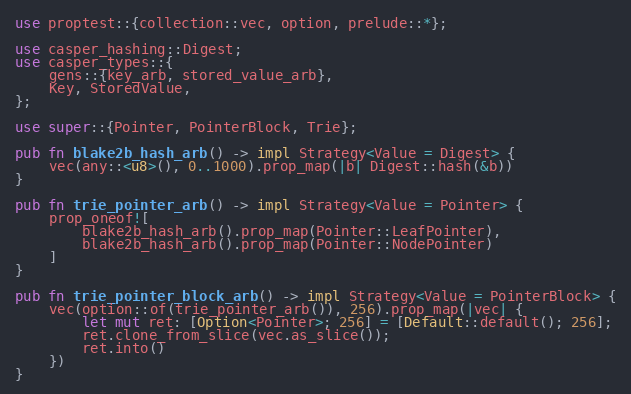Convert code to text. <code><loc_0><loc_0><loc_500><loc_500><_Rust_>use proptest::{collection::vec, option, prelude::*};

use casper_hashing::Digest;
use casper_types::{
    gens::{key_arb, stored_value_arb},
    Key, StoredValue,
};

use super::{Pointer, PointerBlock, Trie};

pub fn blake2b_hash_arb() -> impl Strategy<Value = Digest> {
    vec(any::<u8>(), 0..1000).prop_map(|b| Digest::hash(&b))
}

pub fn trie_pointer_arb() -> impl Strategy<Value = Pointer> {
    prop_oneof![
        blake2b_hash_arb().prop_map(Pointer::LeafPointer),
        blake2b_hash_arb().prop_map(Pointer::NodePointer)
    ]
}

pub fn trie_pointer_block_arb() -> impl Strategy<Value = PointerBlock> {
    vec(option::of(trie_pointer_arb()), 256).prop_map(|vec| {
        let mut ret: [Option<Pointer>; 256] = [Default::default(); 256];
        ret.clone_from_slice(vec.as_slice());
        ret.into()
    })
}
</code> 